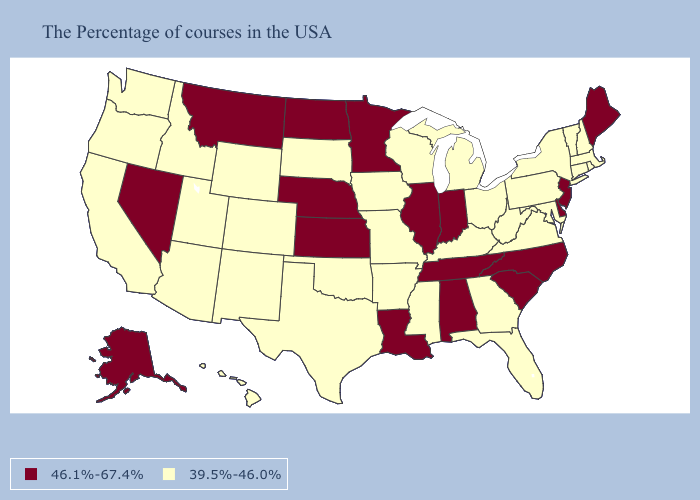Among the states that border Mississippi , does Louisiana have the lowest value?
Give a very brief answer. No. Does Virginia have the highest value in the USA?
Keep it brief. No. What is the highest value in the USA?
Keep it brief. 46.1%-67.4%. What is the value of Alabama?
Keep it brief. 46.1%-67.4%. Name the states that have a value in the range 39.5%-46.0%?
Write a very short answer. Massachusetts, Rhode Island, New Hampshire, Vermont, Connecticut, New York, Maryland, Pennsylvania, Virginia, West Virginia, Ohio, Florida, Georgia, Michigan, Kentucky, Wisconsin, Mississippi, Missouri, Arkansas, Iowa, Oklahoma, Texas, South Dakota, Wyoming, Colorado, New Mexico, Utah, Arizona, Idaho, California, Washington, Oregon, Hawaii. What is the value of Maryland?
Answer briefly. 39.5%-46.0%. Does Louisiana have the lowest value in the USA?
Keep it brief. No. What is the value of New Mexico?
Answer briefly. 39.5%-46.0%. What is the value of Georgia?
Short answer required. 39.5%-46.0%. Among the states that border Illinois , does Iowa have the highest value?
Keep it brief. No. What is the value of West Virginia?
Short answer required. 39.5%-46.0%. What is the highest value in the MidWest ?
Write a very short answer. 46.1%-67.4%. What is the value of Maryland?
Write a very short answer. 39.5%-46.0%. Does Delaware have the highest value in the USA?
Give a very brief answer. Yes. Does the map have missing data?
Give a very brief answer. No. 